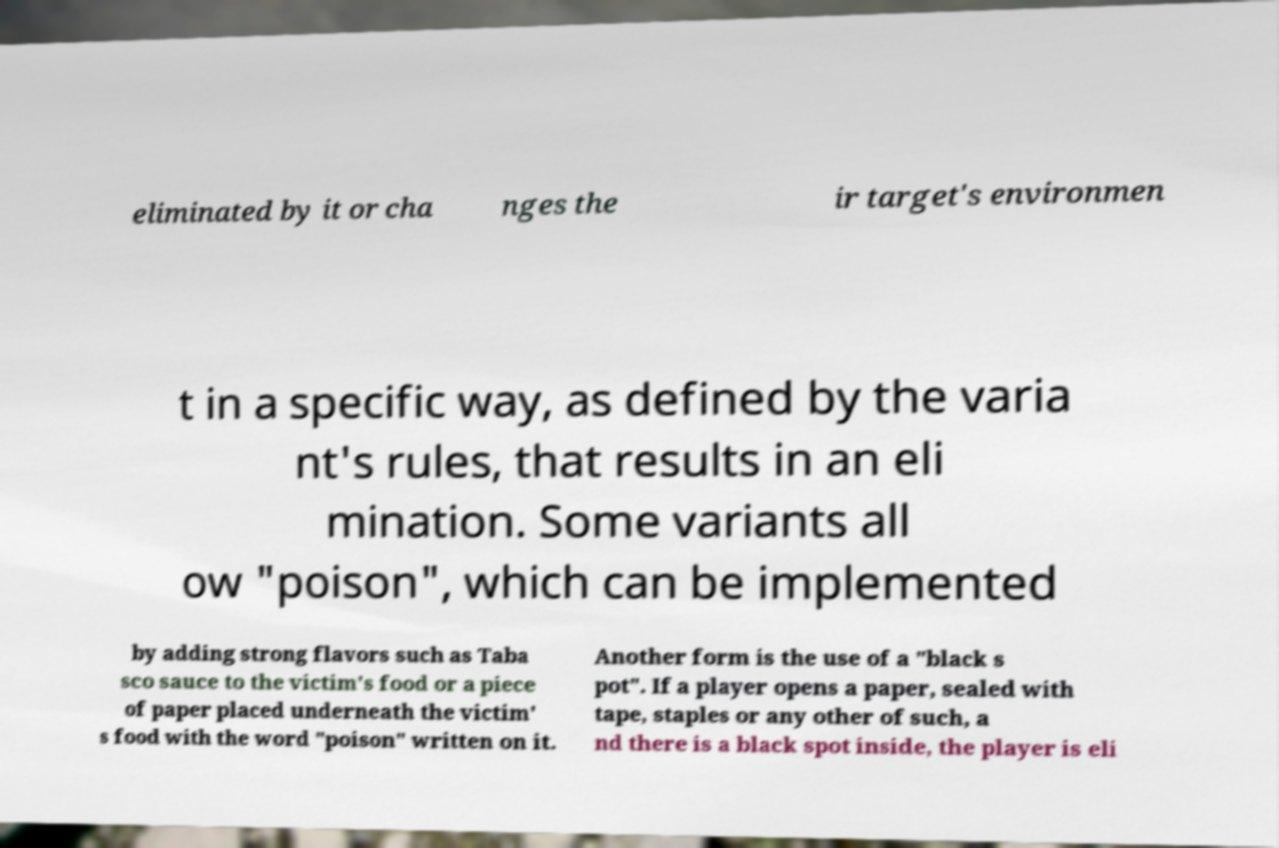Please identify and transcribe the text found in this image. eliminated by it or cha nges the ir target's environmen t in a specific way, as defined by the varia nt's rules, that results in an eli mination. Some variants all ow "poison", which can be implemented by adding strong flavors such as Taba sco sauce to the victim's food or a piece of paper placed underneath the victim' s food with the word "poison" written on it. Another form is the use of a "black s pot". If a player opens a paper, sealed with tape, staples or any other of such, a nd there is a black spot inside, the player is eli 